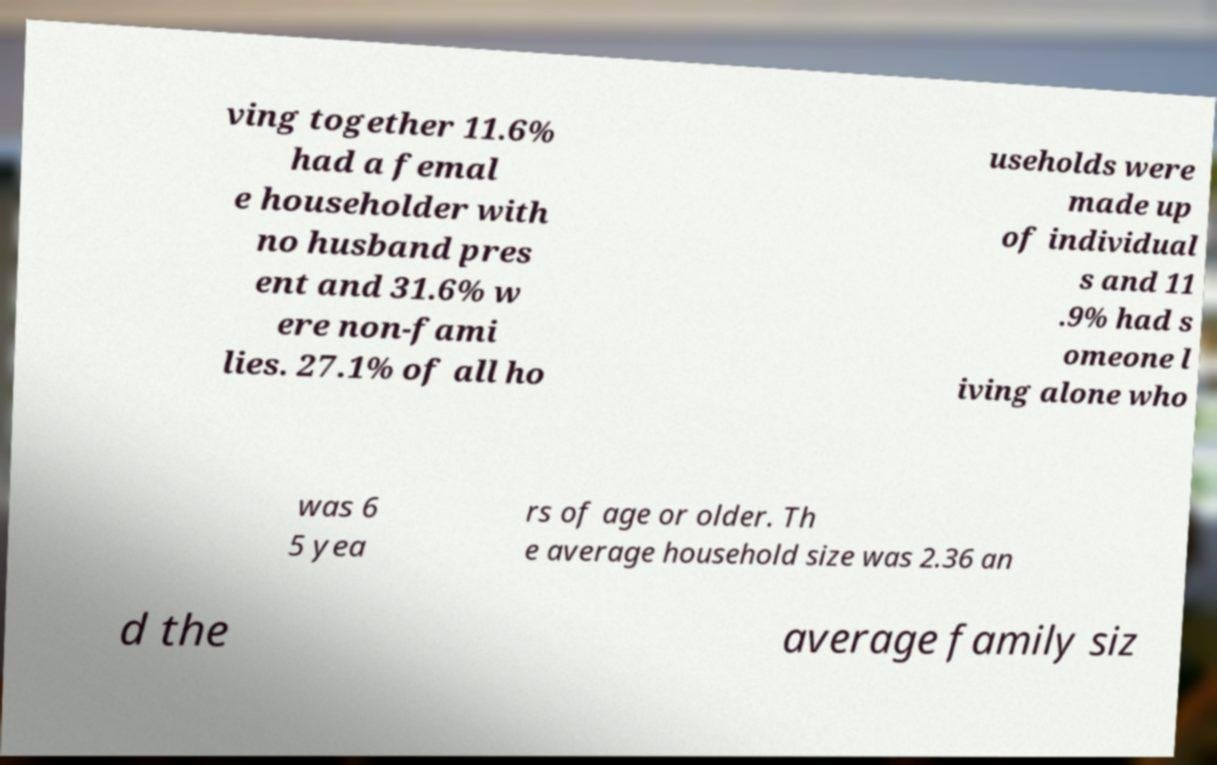Please read and relay the text visible in this image. What does it say? ving together 11.6% had a femal e householder with no husband pres ent and 31.6% w ere non-fami lies. 27.1% of all ho useholds were made up of individual s and 11 .9% had s omeone l iving alone who was 6 5 yea rs of age or older. Th e average household size was 2.36 an d the average family siz 